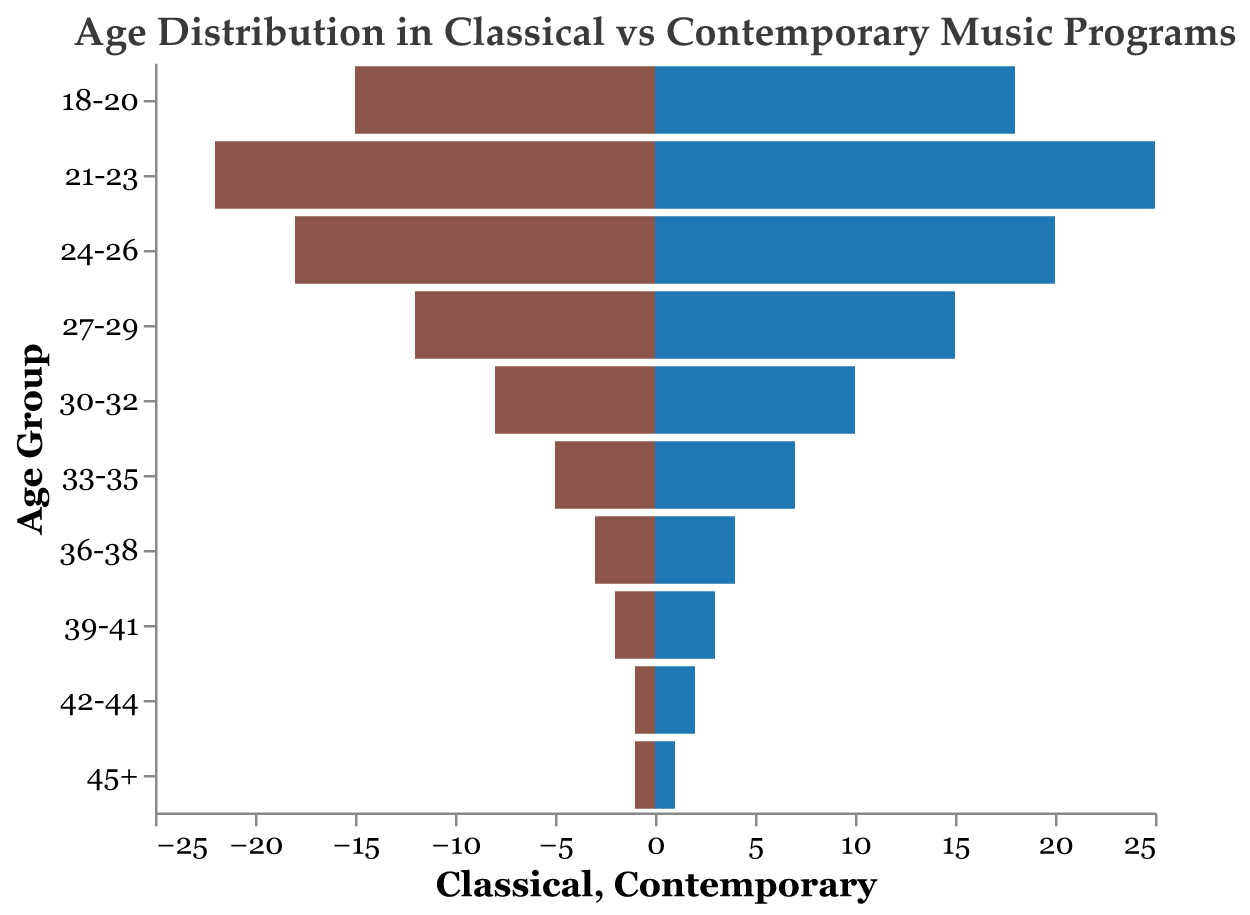What's the title of the figure? The title is written at the top of the figure.
Answer: Age Distribution in Classical vs Contemporary Music Programs Which age group has the highest number of students in the Classical program? Look along the "Classical" axis to see which bar extends the farthest; it corresponds to the '21-23' age group.
Answer: 21-23 How many students in total are in the 30-32 age group across both programs? Add the numbers of students in both Classical and Contemporary programs for this age group (8 + 10).
Answer: 18 For the 24-26 age group, which program has more students and by how much? Compare the lengths of the bars for both programs in the 24-26 age group. Subtract the number of 'Classical' students from 'Contemporary' students (20 - 18).
Answer: Contemporary, 2 Which program starts seeing a drop in student numbers first, and at which age group does this occur? Identify the first significant visible decrease in one of the bars across age groups.
Answer: Classical, 27-29 What's the difference in the number of students between Classical and Contemporary programs for ages 39-41? Subtract the number of Classical students from the number of Contemporary students (3 - 2).
Answer: 1 What is the overall trend in student numbers as age increases in both programs? Analyze the bars from youngest to oldest to note if they generally decrease, increase or remain the same.
Answer: Generally decrease Between which age groups do you see the smallest difference in student numbers for the Contemporary program? Identify two consecutive age groups where the difference in bar heights is minimal. For instance, the difference between 18-20 and 21-23 might be smaller than between other consecutive groups.
Answer: 42-44 and 45+ How many age groups have more students in the Contemporary program compared to the Classical program? Count the age groups where the Contemporary bar is longer than the Classical bar.
Answer: 9 Is there an age group where the number of students is the same in both programs? If so, which one? Look for age groups where both bars have the same length.
Answer: 45+ 